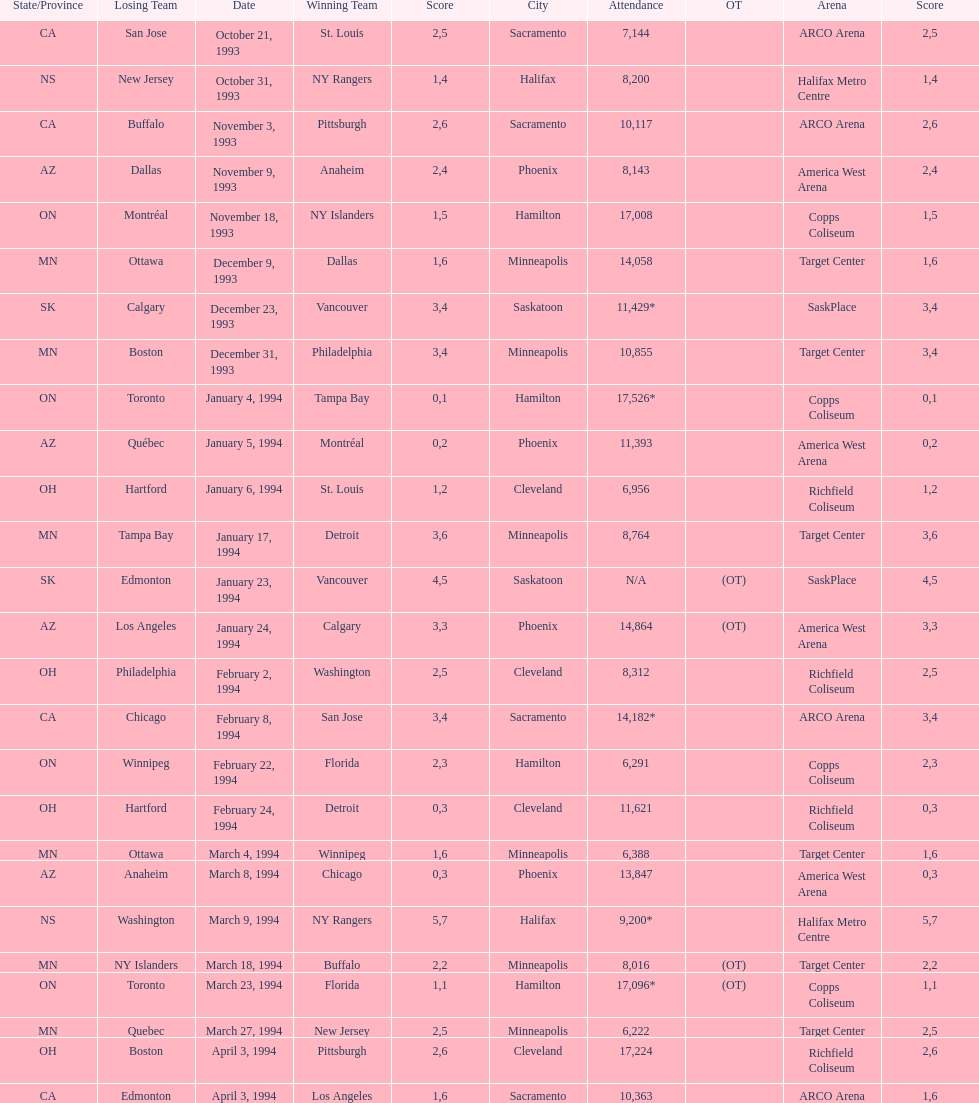Did dallas or ottawa win the december 9, 1993 game? Dallas. 